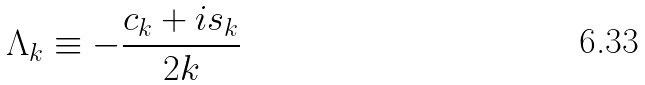<formula> <loc_0><loc_0><loc_500><loc_500>\Lambda _ { k } \equiv - \frac { c _ { k } + i s _ { k } } { 2 k }</formula> 